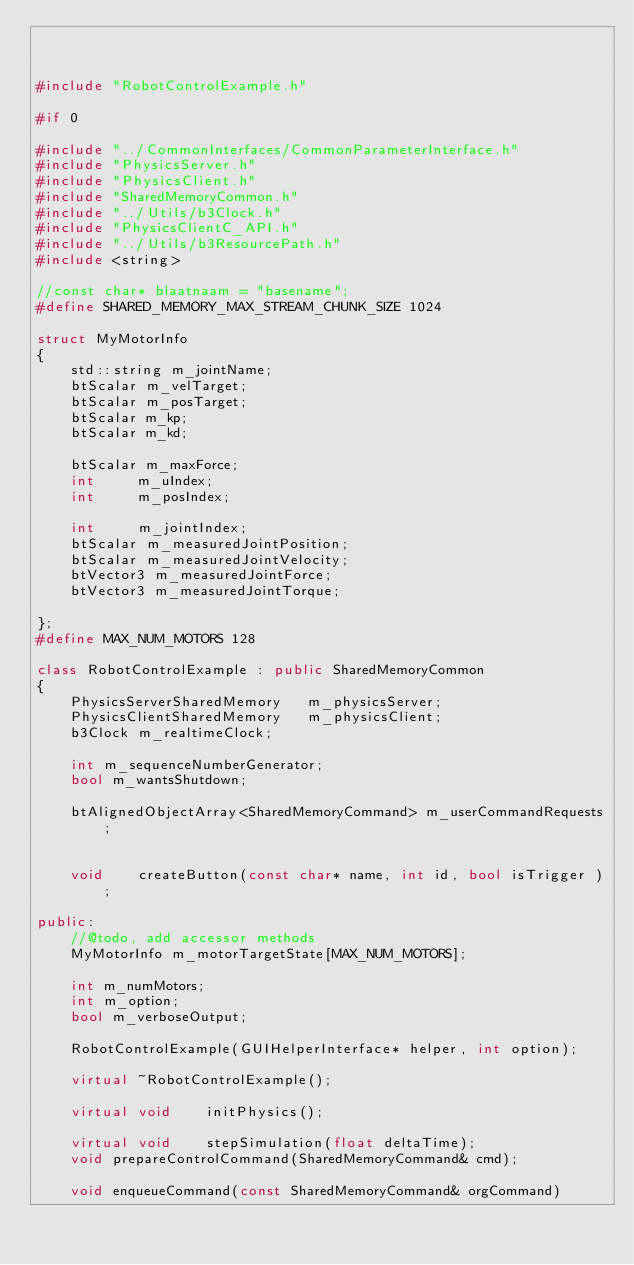Convert code to text. <code><loc_0><loc_0><loc_500><loc_500><_C++_>


#include "RobotControlExample.h"

#if 0

#include "../CommonInterfaces/CommonParameterInterface.h"
#include "PhysicsServer.h"
#include "PhysicsClient.h"
#include "SharedMemoryCommon.h"
#include "../Utils/b3Clock.h"
#include "PhysicsClientC_API.h"
#include "../Utils/b3ResourcePath.h"
#include <string>

//const char* blaatnaam = "basename";
#define SHARED_MEMORY_MAX_STREAM_CHUNK_SIZE 1024

struct MyMotorInfo
{
	std::string m_jointName;
	btScalar m_velTarget;
	btScalar m_posTarget;
    btScalar m_kp;
    btScalar m_kd;
    
	btScalar m_maxForce;
	int		m_uIndex;
	int		m_posIndex;

	int		m_jointIndex;
	btScalar m_measuredJointPosition;
	btScalar m_measuredJointVelocity;
	btVector3 m_measuredJointForce;
	btVector3 m_measuredJointTorque;
	
};
#define MAX_NUM_MOTORS 128

class RobotControlExample : public SharedMemoryCommon
{
	PhysicsServerSharedMemory	m_physicsServer;
	PhysicsClientSharedMemory	m_physicsClient;
	b3Clock	m_realtimeClock;

	int	m_sequenceNumberGenerator;
	bool m_wantsShutdown;
	   
	btAlignedObjectArray<SharedMemoryCommand> m_userCommandRequests;
	
		
	void	createButton(const char* name, int id, bool isTrigger );
	
public:
    //@todo, add accessor methods
	MyMotorInfo m_motorTargetState[MAX_NUM_MOTORS];

	int m_numMotors;
	int m_option;
	bool m_verboseOutput;

	RobotControlExample(GUIHelperInterface* helper, int option);
    
	virtual ~RobotControlExample();
    
	virtual void	initPhysics();
    
	virtual void	stepSimulation(float deltaTime);
    void prepareControlCommand(SharedMemoryCommand& cmd);

    void enqueueCommand(const SharedMemoryCommand& orgCommand)</code> 